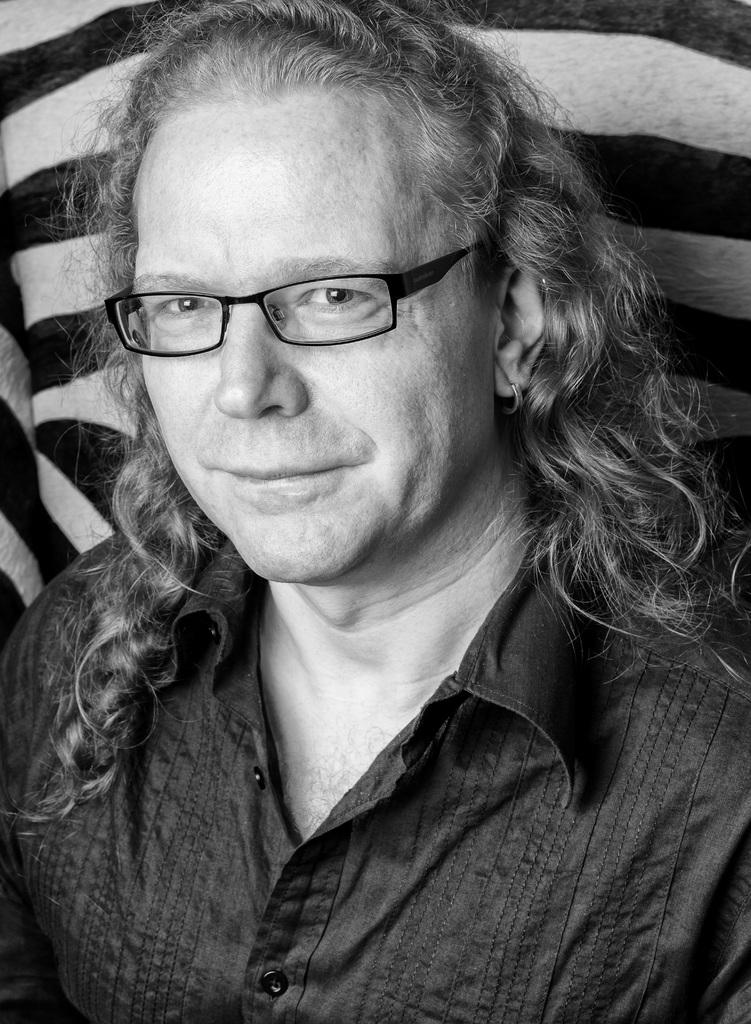What is the main subject of the image? The main subject of the image is a man. What is the man doing in the image? The man is standing and playing a guitar. What is the man wearing in the image? The man is wearing a black shirt. What can be seen in the background of the image? There is a black and white surface in the background of the image. What type of attraction is the man visiting in the image? There is no indication of an attraction in the image; it simply shows a man standing and playing a guitar. What level of expertise does the man have in playing the guitar? The image does not provide information about the man's skill level in playing the guitar. 